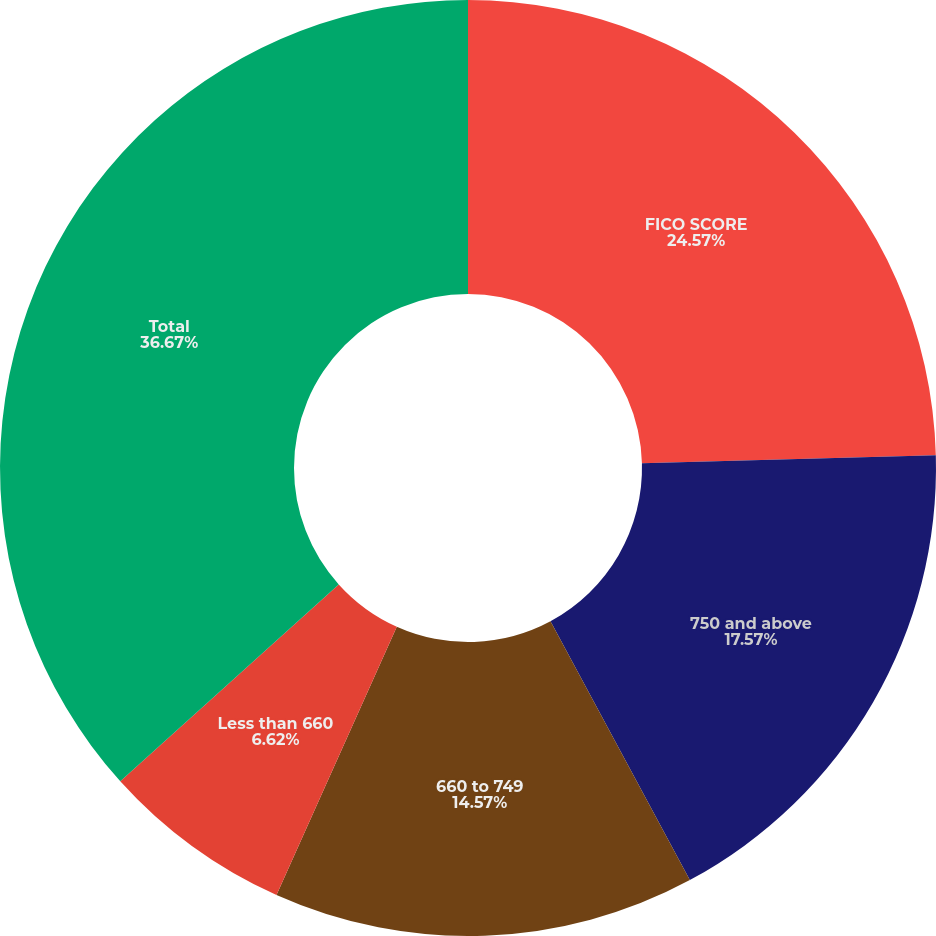Convert chart to OTSL. <chart><loc_0><loc_0><loc_500><loc_500><pie_chart><fcel>FICO SCORE<fcel>750 and above<fcel>660 to 749<fcel>Less than 660<fcel>Total<nl><fcel>24.57%<fcel>17.57%<fcel>14.57%<fcel>6.62%<fcel>36.67%<nl></chart> 